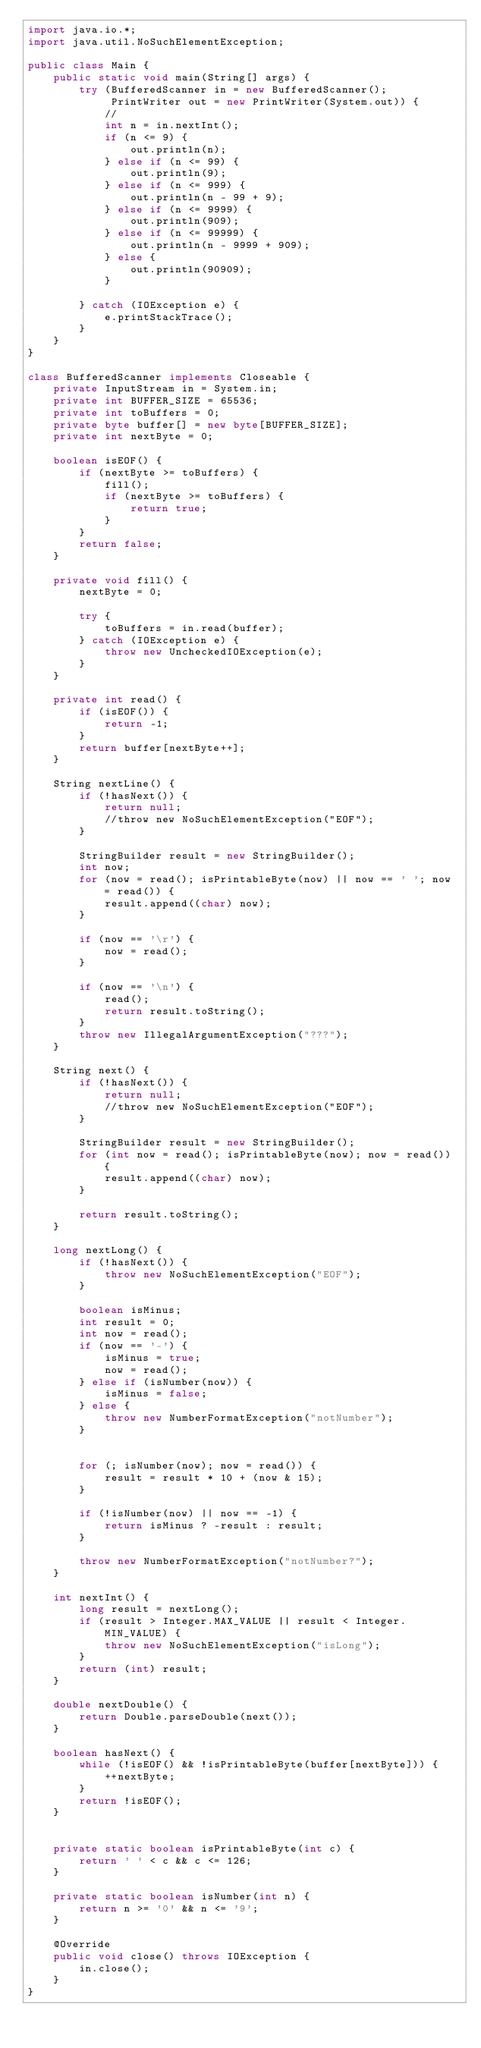Convert code to text. <code><loc_0><loc_0><loc_500><loc_500><_Java_>import java.io.*;
import java.util.NoSuchElementException;

public class Main {
    public static void main(String[] args) {
        try (BufferedScanner in = new BufferedScanner();
             PrintWriter out = new PrintWriter(System.out)) {
            //
            int n = in.nextInt();
            if (n <= 9) {
                out.println(n);
            } else if (n <= 99) {
                out.println(9);
            } else if (n <= 999) {
                out.println(n - 99 + 9);
            } else if (n <= 9999) {
                out.println(909);
            } else if (n <= 99999) {
                out.println(n - 9999 + 909);
            } else {
                out.println(90909);
            }

        } catch (IOException e) {
            e.printStackTrace();
        }
    }
}

class BufferedScanner implements Closeable {
    private InputStream in = System.in;
    private int BUFFER_SIZE = 65536;
    private int toBuffers = 0;
    private byte buffer[] = new byte[BUFFER_SIZE];
    private int nextByte = 0;

    boolean isEOF() {
        if (nextByte >= toBuffers) {
            fill();
            if (nextByte >= toBuffers) {
                return true;
            }
        }
        return false;
    }

    private void fill() {
        nextByte = 0;

        try {
            toBuffers = in.read(buffer);
        } catch (IOException e) {
            throw new UncheckedIOException(e);
        }
    }

    private int read() {
        if (isEOF()) {
            return -1;
        }
        return buffer[nextByte++];
    }

    String nextLine() {
        if (!hasNext()) {
            return null;
            //throw new NoSuchElementException("EOF");
        }

        StringBuilder result = new StringBuilder();
        int now;
        for (now = read(); isPrintableByte(now) || now == ' '; now = read()) {
            result.append((char) now);
        }

        if (now == '\r') {
            now = read();
        }

        if (now == '\n') {
            read();
            return result.toString();
        }
        throw new IllegalArgumentException("???");
    }

    String next() {
        if (!hasNext()) {
            return null;
            //throw new NoSuchElementException("EOF");
        }

        StringBuilder result = new StringBuilder();
        for (int now = read(); isPrintableByte(now); now = read()) {
            result.append((char) now);
        }

        return result.toString();
    }

    long nextLong() {
        if (!hasNext()) {
            throw new NoSuchElementException("EOF");
        }

        boolean isMinus;
        int result = 0;
        int now = read();
        if (now == '-') {
            isMinus = true;
            now = read();
        } else if (isNumber(now)) {
            isMinus = false;
        } else {
            throw new NumberFormatException("notNumber");
        }


        for (; isNumber(now); now = read()) {
            result = result * 10 + (now & 15);
        }

        if (!isNumber(now) || now == -1) {
            return isMinus ? -result : result;
        }

        throw new NumberFormatException("notNumber?");
    }

    int nextInt() {
        long result = nextLong();
        if (result > Integer.MAX_VALUE || result < Integer.MIN_VALUE) {
            throw new NoSuchElementException("isLong");
        }
        return (int) result;
    }

    double nextDouble() {
        return Double.parseDouble(next());
    }

    boolean hasNext() {
        while (!isEOF() && !isPrintableByte(buffer[nextByte])) {
            ++nextByte;
        }
        return !isEOF();
    }


    private static boolean isPrintableByte(int c) {
        return ' ' < c && c <= 126;
    }

    private static boolean isNumber(int n) {
        return n >= '0' && n <= '9';
    }

    @Override
    public void close() throws IOException {
        in.close();
    }
}
</code> 